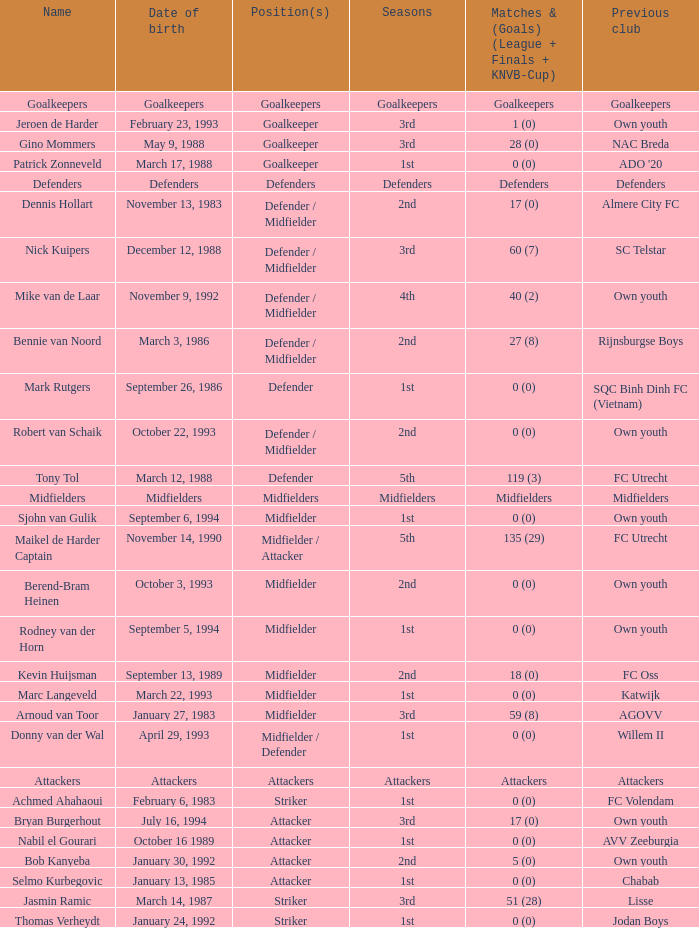What club, now defunct, was founded on october 22, 1993? Own youth. Parse the table in full. {'header': ['Name', 'Date of birth', 'Position(s)', 'Seasons', 'Matches & (Goals) (League + Finals + KNVB-Cup)', 'Previous club'], 'rows': [['Goalkeepers', 'Goalkeepers', 'Goalkeepers', 'Goalkeepers', 'Goalkeepers', 'Goalkeepers'], ['Jeroen de Harder', 'February 23, 1993', 'Goalkeeper', '3rd', '1 (0)', 'Own youth'], ['Gino Mommers', 'May 9, 1988', 'Goalkeeper', '3rd', '28 (0)', 'NAC Breda'], ['Patrick Zonneveld', 'March 17, 1988', 'Goalkeeper', '1st', '0 (0)', "ADO '20"], ['Defenders', 'Defenders', 'Defenders', 'Defenders', 'Defenders', 'Defenders'], ['Dennis Hollart', 'November 13, 1983', 'Defender / Midfielder', '2nd', '17 (0)', 'Almere City FC'], ['Nick Kuipers', 'December 12, 1988', 'Defender / Midfielder', '3rd', '60 (7)', 'SC Telstar'], ['Mike van de Laar', 'November 9, 1992', 'Defender / Midfielder', '4th', '40 (2)', 'Own youth'], ['Bennie van Noord', 'March 3, 1986', 'Defender / Midfielder', '2nd', '27 (8)', 'Rijnsburgse Boys'], ['Mark Rutgers', 'September 26, 1986', 'Defender', '1st', '0 (0)', 'SQC Binh Dinh FC (Vietnam)'], ['Robert van Schaik', 'October 22, 1993', 'Defender / Midfielder', '2nd', '0 (0)', 'Own youth'], ['Tony Tol', 'March 12, 1988', 'Defender', '5th', '119 (3)', 'FC Utrecht'], ['Midfielders', 'Midfielders', 'Midfielders', 'Midfielders', 'Midfielders', 'Midfielders'], ['Sjohn van Gulik', 'September 6, 1994', 'Midfielder', '1st', '0 (0)', 'Own youth'], ['Maikel de Harder Captain', 'November 14, 1990', 'Midfielder / Attacker', '5th', '135 (29)', 'FC Utrecht'], ['Berend-Bram Heinen', 'October 3, 1993', 'Midfielder', '2nd', '0 (0)', 'Own youth'], ['Rodney van der Horn', 'September 5, 1994', 'Midfielder', '1st', '0 (0)', 'Own youth'], ['Kevin Huijsman', 'September 13, 1989', 'Midfielder', '2nd', '18 (0)', 'FC Oss'], ['Marc Langeveld', 'March 22, 1993', 'Midfielder', '1st', '0 (0)', 'Katwijk'], ['Arnoud van Toor', 'January 27, 1983', 'Midfielder', '3rd', '59 (8)', 'AGOVV'], ['Donny van der Wal', 'April 29, 1993', 'Midfielder / Defender', '1st', '0 (0)', 'Willem II'], ['Attackers', 'Attackers', 'Attackers', 'Attackers', 'Attackers', 'Attackers'], ['Achmed Ahahaoui', 'February 6, 1983', 'Striker', '1st', '0 (0)', 'FC Volendam'], ['Bryan Burgerhout', 'July 16, 1994', 'Attacker', '3rd', '17 (0)', 'Own youth'], ['Nabil el Gourari', 'October 16 1989', 'Attacker', '1st', '0 (0)', 'AVV Zeeburgia'], ['Bob Kanyeba', 'January 30, 1992', 'Attacker', '2nd', '5 (0)', 'Own youth'], ['Selmo Kurbegovic', 'January 13, 1985', 'Attacker', '1st', '0 (0)', 'Chabab'], ['Jasmin Ramic', 'March 14, 1987', 'Striker', '3rd', '51 (28)', 'Lisse'], ['Thomas Verheydt', 'January 24, 1992', 'Striker', '1st', '0 (0)', 'Jodan Boys']]} 